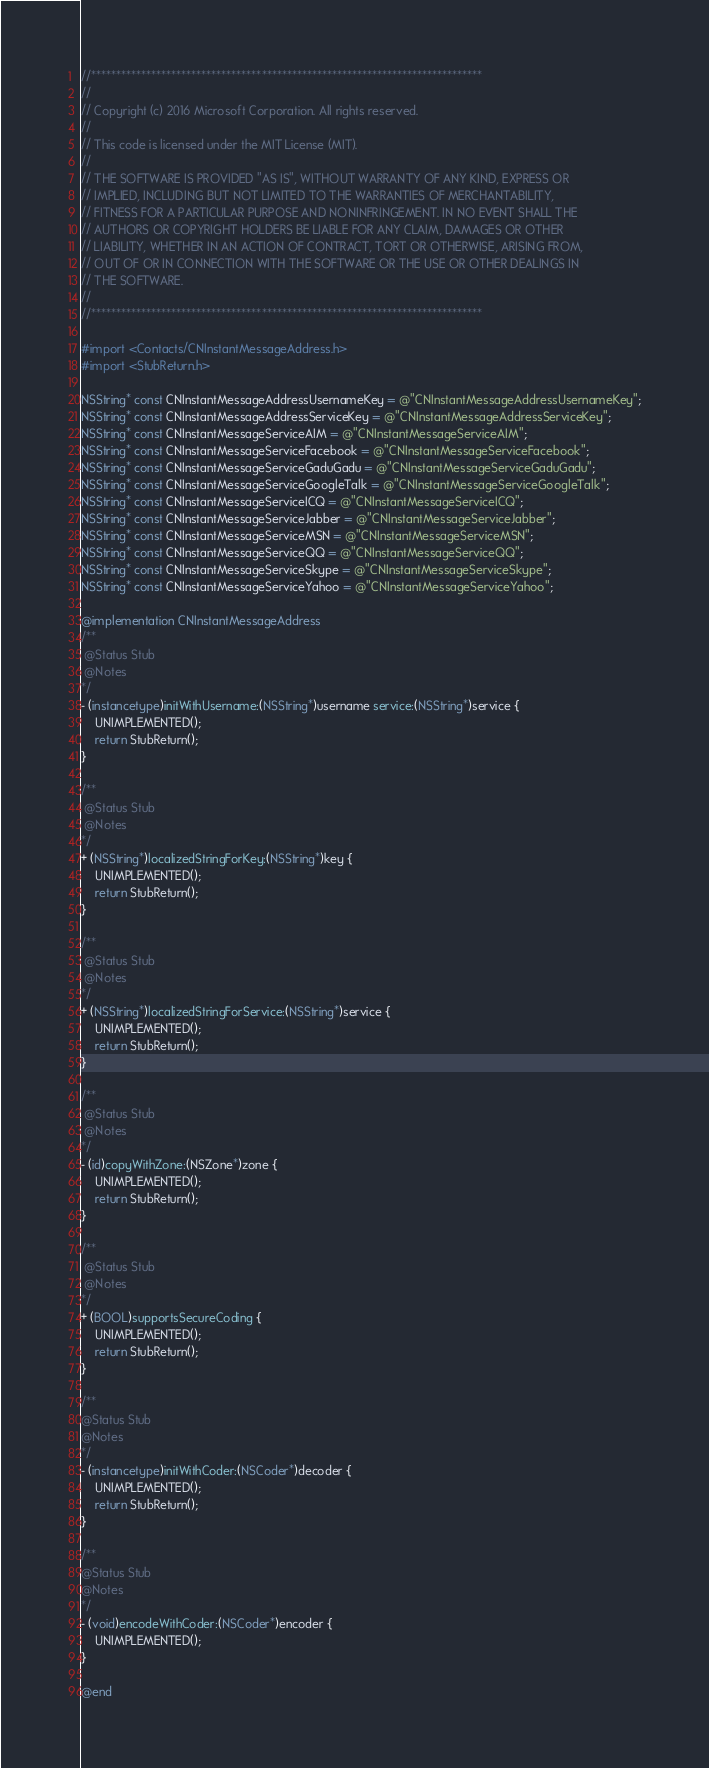Convert code to text. <code><loc_0><loc_0><loc_500><loc_500><_ObjectiveC_>//******************************************************************************
//
// Copyright (c) 2016 Microsoft Corporation. All rights reserved.
//
// This code is licensed under the MIT License (MIT).
//
// THE SOFTWARE IS PROVIDED "AS IS", WITHOUT WARRANTY OF ANY KIND, EXPRESS OR
// IMPLIED, INCLUDING BUT NOT LIMITED TO THE WARRANTIES OF MERCHANTABILITY,
// FITNESS FOR A PARTICULAR PURPOSE AND NONINFRINGEMENT. IN NO EVENT SHALL THE
// AUTHORS OR COPYRIGHT HOLDERS BE LIABLE FOR ANY CLAIM, DAMAGES OR OTHER
// LIABILITY, WHETHER IN AN ACTION OF CONTRACT, TORT OR OTHERWISE, ARISING FROM,
// OUT OF OR IN CONNECTION WITH THE SOFTWARE OR THE USE OR OTHER DEALINGS IN
// THE SOFTWARE.
//
//******************************************************************************

#import <Contacts/CNInstantMessageAddress.h>
#import <StubReturn.h>

NSString* const CNInstantMessageAddressUsernameKey = @"CNInstantMessageAddressUsernameKey";
NSString* const CNInstantMessageAddressServiceKey = @"CNInstantMessageAddressServiceKey";
NSString* const CNInstantMessageServiceAIM = @"CNInstantMessageServiceAIM";
NSString* const CNInstantMessageServiceFacebook = @"CNInstantMessageServiceFacebook";
NSString* const CNInstantMessageServiceGaduGadu = @"CNInstantMessageServiceGaduGadu";
NSString* const CNInstantMessageServiceGoogleTalk = @"CNInstantMessageServiceGoogleTalk";
NSString* const CNInstantMessageServiceICQ = @"CNInstantMessageServiceICQ";
NSString* const CNInstantMessageServiceJabber = @"CNInstantMessageServiceJabber";
NSString* const CNInstantMessageServiceMSN = @"CNInstantMessageServiceMSN";
NSString* const CNInstantMessageServiceQQ = @"CNInstantMessageServiceQQ";
NSString* const CNInstantMessageServiceSkype = @"CNInstantMessageServiceSkype";
NSString* const CNInstantMessageServiceYahoo = @"CNInstantMessageServiceYahoo";

@implementation CNInstantMessageAddress
/**
 @Status Stub
 @Notes
*/
- (instancetype)initWithUsername:(NSString*)username service:(NSString*)service {
    UNIMPLEMENTED();
    return StubReturn();
}

/**
 @Status Stub
 @Notes
*/
+ (NSString*)localizedStringForKey:(NSString*)key {
    UNIMPLEMENTED();
    return StubReturn();
}

/**
 @Status Stub
 @Notes
*/
+ (NSString*)localizedStringForService:(NSString*)service {
    UNIMPLEMENTED();
    return StubReturn();
}

/**
 @Status Stub
 @Notes
*/
- (id)copyWithZone:(NSZone*)zone {
    UNIMPLEMENTED();
    return StubReturn();
}

/**
 @Status Stub
 @Notes
*/
+ (BOOL)supportsSecureCoding {
    UNIMPLEMENTED();
    return StubReturn();
}

/**
@Status Stub
@Notes
*/
- (instancetype)initWithCoder:(NSCoder*)decoder {
    UNIMPLEMENTED();
    return StubReturn();
}

/**
@Status Stub
@Notes
*/
- (void)encodeWithCoder:(NSCoder*)encoder {
    UNIMPLEMENTED();
}

@end
</code> 